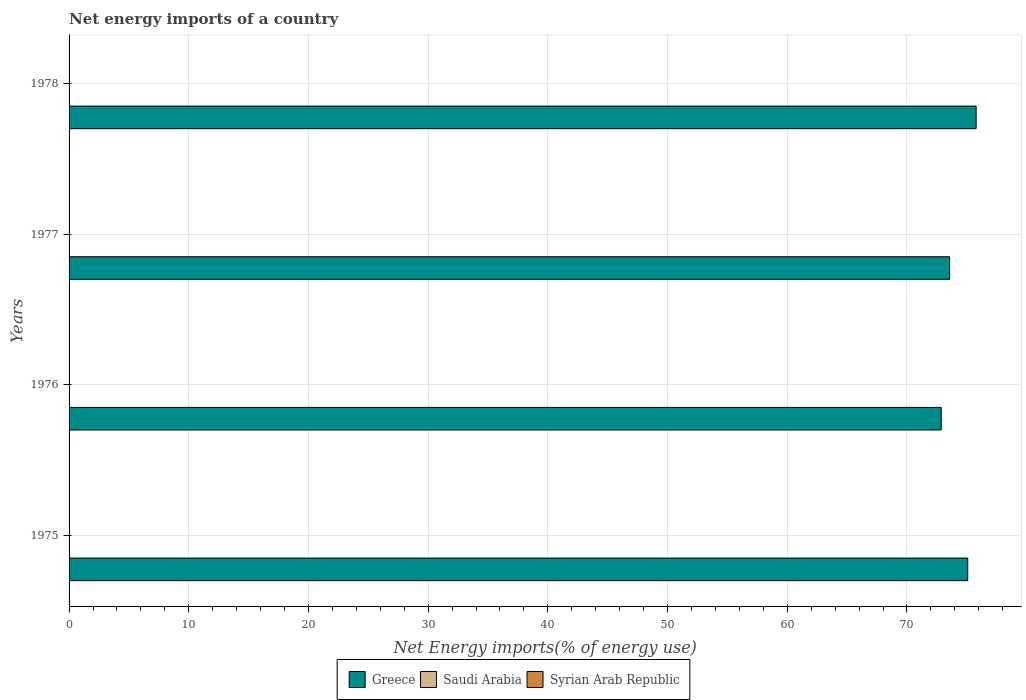How many different coloured bars are there?
Keep it short and to the point. 1. Are the number of bars on each tick of the Y-axis equal?
Provide a succinct answer. Yes. What is the label of the 3rd group of bars from the top?
Your answer should be very brief. 1976. In how many cases, is the number of bars for a given year not equal to the number of legend labels?
Ensure brevity in your answer.  4. What is the net energy imports in Greece in 1978?
Ensure brevity in your answer.  75.78. Across all years, what is the minimum net energy imports in Greece?
Offer a terse response. 72.86. In which year was the net energy imports in Greece maximum?
Keep it short and to the point. 1978. What is the total net energy imports in Syrian Arab Republic in the graph?
Your answer should be compact. 0. What is the difference between the net energy imports in Greece in 1977 and that in 1978?
Give a very brief answer. -2.21. What is the difference between the net energy imports in Syrian Arab Republic in 1977 and the net energy imports in Saudi Arabia in 1975?
Give a very brief answer. 0. What is the average net energy imports in Greece per year?
Ensure brevity in your answer.  74.32. In how many years, is the net energy imports in Greece greater than 40 %?
Provide a short and direct response. 4. What is the ratio of the net energy imports in Greece in 1976 to that in 1977?
Offer a very short reply. 0.99. Is the net energy imports in Greece in 1976 less than that in 1977?
Keep it short and to the point. Yes. What is the difference between the highest and the second highest net energy imports in Greece?
Ensure brevity in your answer.  0.7. What is the difference between the highest and the lowest net energy imports in Greece?
Offer a very short reply. 2.92. Are all the bars in the graph horizontal?
Your answer should be compact. Yes. How are the legend labels stacked?
Your response must be concise. Horizontal. What is the title of the graph?
Ensure brevity in your answer.  Net energy imports of a country. What is the label or title of the X-axis?
Your response must be concise. Net Energy imports(% of energy use). What is the label or title of the Y-axis?
Your response must be concise. Years. What is the Net Energy imports(% of energy use) in Greece in 1975?
Make the answer very short. 75.08. What is the Net Energy imports(% of energy use) of Saudi Arabia in 1975?
Provide a succinct answer. 0. What is the Net Energy imports(% of energy use) of Syrian Arab Republic in 1975?
Ensure brevity in your answer.  0. What is the Net Energy imports(% of energy use) of Greece in 1976?
Your response must be concise. 72.86. What is the Net Energy imports(% of energy use) of Saudi Arabia in 1976?
Give a very brief answer. 0. What is the Net Energy imports(% of energy use) in Syrian Arab Republic in 1976?
Provide a succinct answer. 0. What is the Net Energy imports(% of energy use) of Greece in 1977?
Provide a succinct answer. 73.57. What is the Net Energy imports(% of energy use) in Greece in 1978?
Your response must be concise. 75.78. What is the Net Energy imports(% of energy use) of Saudi Arabia in 1978?
Keep it short and to the point. 0. Across all years, what is the maximum Net Energy imports(% of energy use) of Greece?
Make the answer very short. 75.78. Across all years, what is the minimum Net Energy imports(% of energy use) of Greece?
Provide a succinct answer. 72.86. What is the total Net Energy imports(% of energy use) of Greece in the graph?
Your response must be concise. 297.28. What is the difference between the Net Energy imports(% of energy use) of Greece in 1975 and that in 1976?
Your response must be concise. 2.21. What is the difference between the Net Energy imports(% of energy use) of Greece in 1975 and that in 1977?
Ensure brevity in your answer.  1.51. What is the difference between the Net Energy imports(% of energy use) of Greece in 1975 and that in 1978?
Provide a succinct answer. -0.7. What is the difference between the Net Energy imports(% of energy use) of Greece in 1976 and that in 1977?
Make the answer very short. -0.7. What is the difference between the Net Energy imports(% of energy use) of Greece in 1976 and that in 1978?
Keep it short and to the point. -2.92. What is the difference between the Net Energy imports(% of energy use) in Greece in 1977 and that in 1978?
Ensure brevity in your answer.  -2.21. What is the average Net Energy imports(% of energy use) in Greece per year?
Offer a very short reply. 74.32. What is the ratio of the Net Energy imports(% of energy use) of Greece in 1975 to that in 1976?
Ensure brevity in your answer.  1.03. What is the ratio of the Net Energy imports(% of energy use) in Greece in 1975 to that in 1977?
Give a very brief answer. 1.02. What is the ratio of the Net Energy imports(% of energy use) in Greece in 1976 to that in 1977?
Ensure brevity in your answer.  0.99. What is the ratio of the Net Energy imports(% of energy use) of Greece in 1976 to that in 1978?
Your answer should be compact. 0.96. What is the ratio of the Net Energy imports(% of energy use) of Greece in 1977 to that in 1978?
Ensure brevity in your answer.  0.97. What is the difference between the highest and the second highest Net Energy imports(% of energy use) of Greece?
Keep it short and to the point. 0.7. What is the difference between the highest and the lowest Net Energy imports(% of energy use) of Greece?
Offer a terse response. 2.92. 